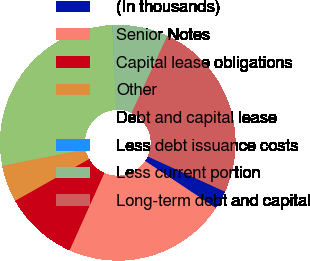Convert chart. <chart><loc_0><loc_0><loc_500><loc_500><pie_chart><fcel>(In thousands)<fcel>Senior Notes<fcel>Capital lease obligations<fcel>Other<fcel>Debt and capital lease<fcel>Less debt issuance costs<fcel>Less current portion<fcel>Long-term debt and capital<nl><fcel>2.55%<fcel>22.36%<fcel>10.11%<fcel>5.07%<fcel>27.4%<fcel>0.03%<fcel>7.59%<fcel>24.88%<nl></chart> 